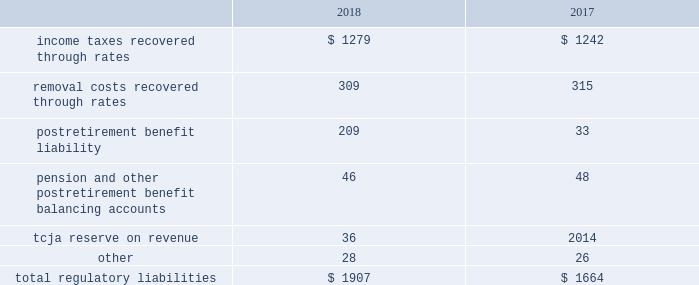Pre-construction costs , interim dam safety measures and environmental costs and construction costs .
The authorized costs were being recovered via a surcharge over a twenty-year period which began in october 2012 .
The unrecovered balance of project costs incurred , including cost of capital , net of surcharges totaled $ 85 million and $ 89 million as of december 31 , 2018 and 2017 , respectively .
Surcharges collected were $ 8 million and $ 7 million for the years ended december 31 , 2018 and 2017 , respectively .
Pursuant to the general rate case approved in december 2018 , approval was granted to reset the twenty-year amortization period to begin january 1 , 2018 and to establish an annual revenue requirement of $ 8 million to be recovered through base rates .
Debt expense is amortized over the lives of the respective issues .
Call premiums on the redemption of long- term debt , as well as unamortized debt expense , are deferred and amortized to the extent they will be recovered through future service rates .
Purchase premium recoverable through rates is primarily the recovery of the acquisition premiums related to an asset acquisition by the company 2019s utility subsidiary in california during 2002 , and acquisitions in 2007 by the company 2019s utility subsidiary in new jersey .
As authorized for recovery by the california and new jersey pucs , these costs are being amortized to depreciation and amortization on the consolidated statements of operations through november 2048 .
Tank painting costs are generally deferred and amortized to operations and maintenance expense on the consolidated statements of operations on a straight-line basis over periods ranging from five to fifteen years , as authorized by the regulatory authorities in their determination of rates charged for service .
As a result of the prepayment by american water capital corp. , the company 2019s wholly owned finance subsidiary ( 201cawcc 201d ) , of the 5.62% ( 5.62 % ) series c senior notes due upon maturity on december 21 , 2018 ( the 201cseries c notes 201d ) , 5.62% ( 5.62 % ) series e senior notes due march 29 , 2019 ( the 201cseries e notes 201d ) and 5.77% ( 5.77 % ) series f senior notes due december 21 , 2022 ( the 201cseries f notes , 201d and together with the series e notes , the 201cseries notes 201d ) , a make-whole premium of $ 10 million was paid to the holders of the series notes on september 11 , 2018 .
Substantially all of these early debt extinguishment costs were allocable to the company 2019s utility subsidiaries and recorded as regulatory assets , as the company believes they are probable of recovery in future rates .
Other regulatory assets include certain construction costs for treatment facilities , property tax stabilization , employee-related costs , deferred other postretirement benefit expense , business services project expenses , coastal water project costs , rate case expenditures and environmental remediation costs among others .
These costs are deferred because the amounts are being recovered in rates or are probable of recovery through rates in future periods .
Regulatory liabilities regulatory liabilities generally represent amounts that are probable of being credited or refunded to customers through the rate-making process .
Also , if costs expected to be incurred in the future are currently being recovered through rates , the company records those expected future costs as regulatory liabilities .
The table provides the composition of regulatory liabilities as of december 31: .

What were total removal costs recovered through rates in milliions? 
Computations: table_sum(removal costs recovered through rates, none)
Answer: 624.0. 